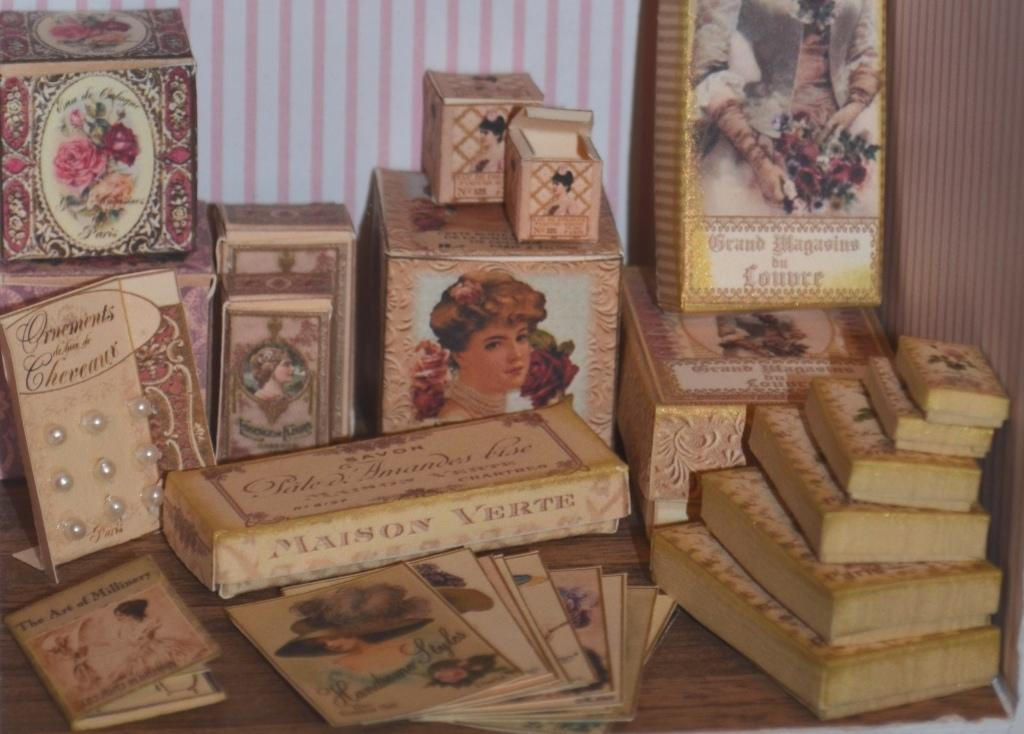What is one object visible in the image? There is a book in the image. What else can be seen besides the book? There are cards and boxes in the image. What type of surface is present in the image? The wooden surface is present in the image. What is on the right side of the image? There is a cloth on the right side of the image. What can be seen in the background of the image? There is a wall in the background of the image. What type of society is depicted in the image? There is no society depicted in the image; it features a book, cards, boxes, a wooden surface, a cloth, and a wall. How many knees can be seen in the image? There are no knees visible in the image. 